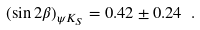Convert formula to latex. <formula><loc_0><loc_0><loc_500><loc_500>( \sin 2 \beta ) _ { \psi K _ { S } } = 0 . 4 2 \pm 0 . 2 4 \ .</formula> 